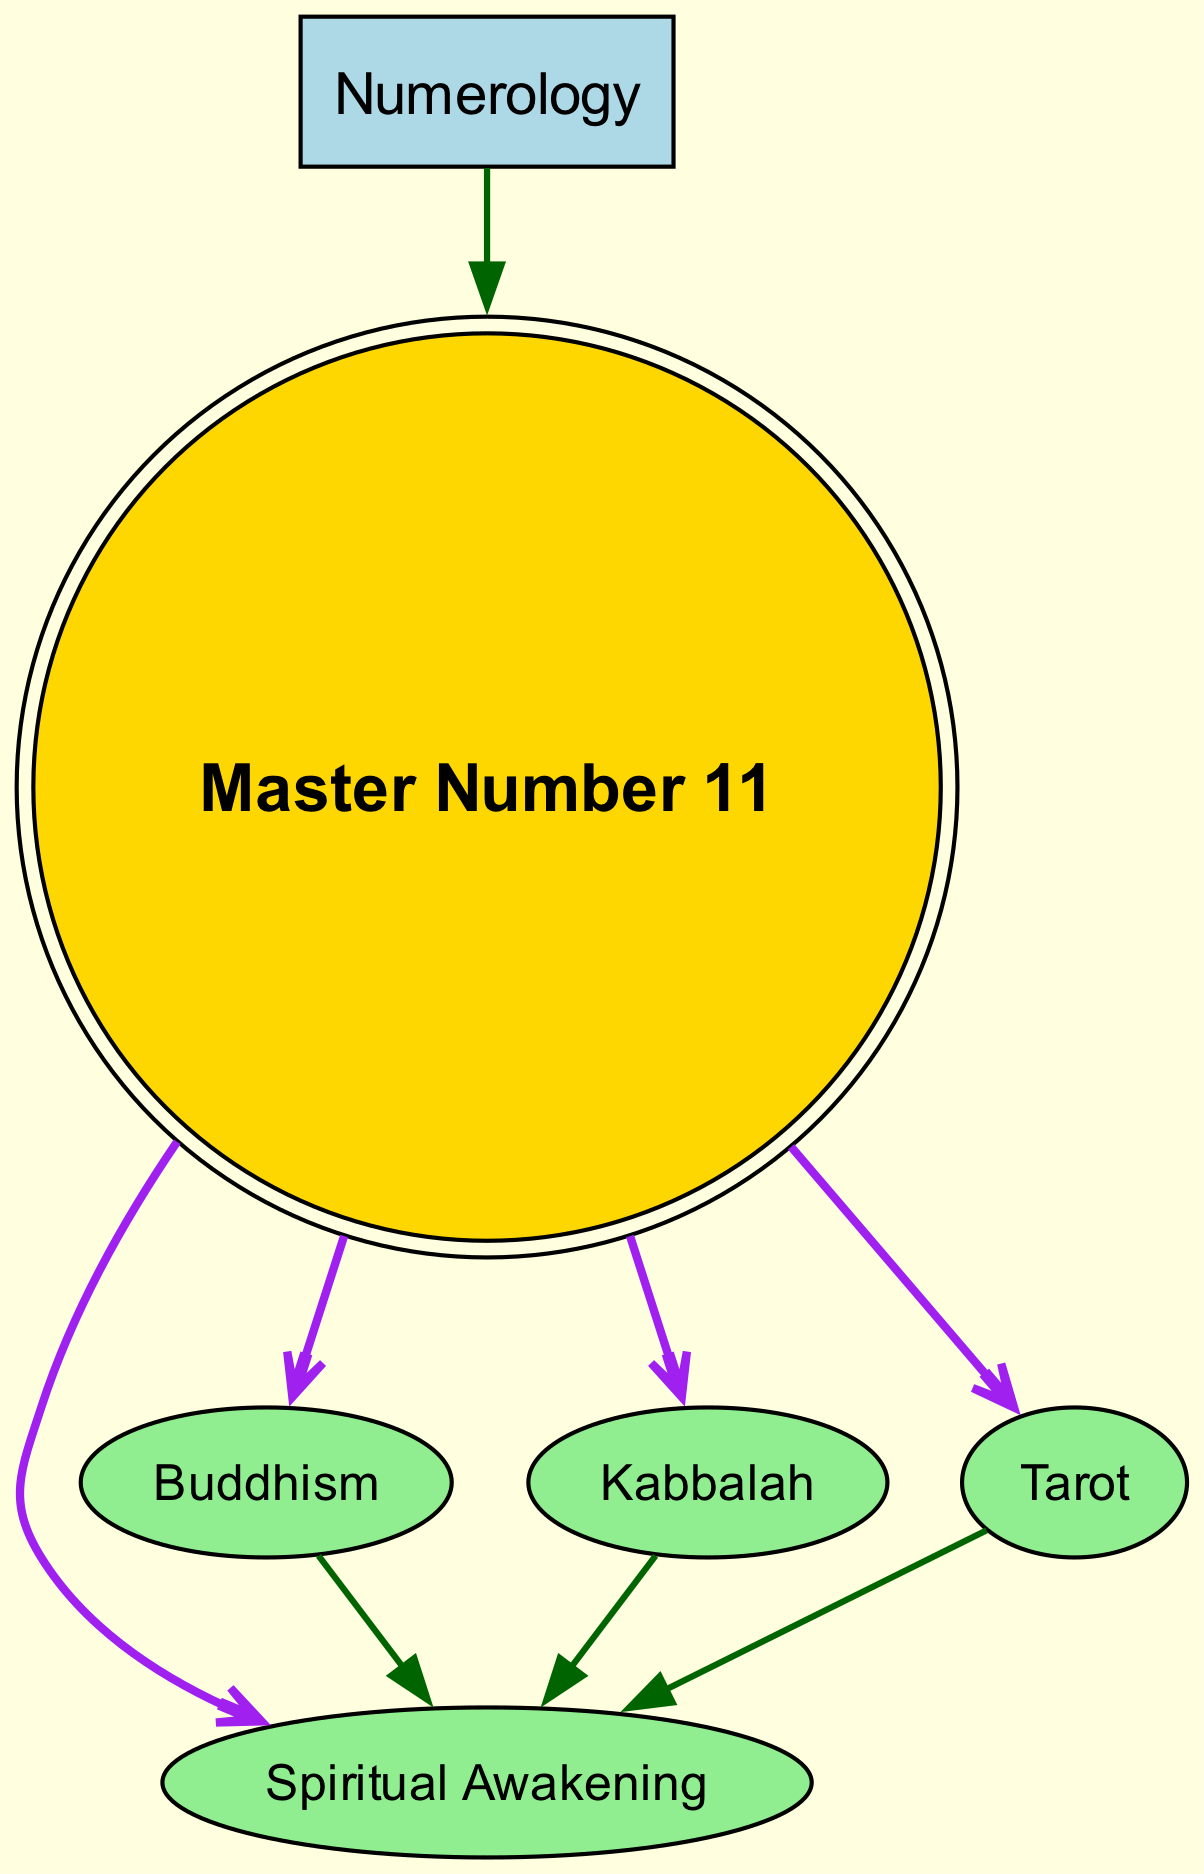What is the total number of nodes in the diagram? By counting each unique node in the provided data, we identify the following nodes: Numerology, Master Number 11, Spiritual Awakening, Buddhism, Kabbalah, and Tarot. This totals to 6 distinct nodes.
Answer: 6 Which node is connected to the Master Number 11? The edges connected to the Master Number 11 show that it points to Spiritual Awakening, Buddhism, Kabbalah, and Tarot. This means all these nodes are directly connected to Master Number 11.
Answer: Spiritual Awakening, Buddhism, Kabbalah, Tarot How many edges are outgoing from the Master Number 11? Observing the connections from Master Number 11, we see that it has four edges leading to Spiritual Awakening, Buddhism, Kabbalah, and Tarot. Therefore, the number of edges outgoing from Master Number 11 is four.
Answer: 4 What spiritual belief is directly linked to both Buddhism and Master Number 11? Looking at the edges from the nodes, both Buddhism and Master Number 11 point to Spiritual Awakening. Hence, the spiritual belief directly linked to both nodes is Spiritual Awakening.
Answer: Spiritual Awakening What is the color of the edge from Master Number 11 to Buddhism? The edge connecting Master Number 11 to Buddhism is depicted in purple, as all edges stemming from Master Number 11 are colored purple in the diagram.
Answer: Purple Which node represents a system that includes the concept of Master Number 11? The node labeled Numerology indicates a system that encompasses the concept of Master Number 11, as it serves as the starting point for the directed graph flow.
Answer: Numerology What is the significance of the number 11 in Kabbalah as illustrated in the diagram? The edge from Kabbalah to Spiritual Awakening suggests that Kabbalah includes or points to the same spiritual awakening associated with Master Number 11, indicating its significance in connection to spiritual beliefs.
Answer: Spiritual Awakening How is the relationship between Tarot and Spiritual Awakening depicted in the diagram? The diagram shows a directed edge from Tarot to Spiritual Awakening, indicating that Tarot promotes or leads to an understanding of Spiritual Awakening, establishing their connection.
Answer: Leads to Spiritual Awakening What is the common outcome associated with all nodes connected to Master Number 11? All nodes connected to Master Number 11 ultimately lead to Spiritual Awakening, indicating that it is a common outcome derived from each of them.
Answer: Spiritual Awakening 